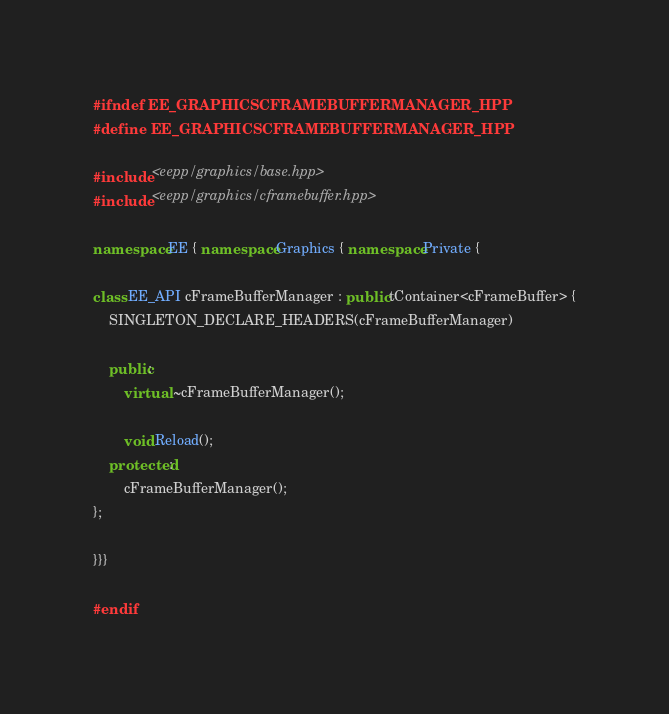<code> <loc_0><loc_0><loc_500><loc_500><_C++_>#ifndef EE_GRAPHICSCFRAMEBUFFERMANAGER_HPP
#define EE_GRAPHICSCFRAMEBUFFERMANAGER_HPP

#include <eepp/graphics/base.hpp>
#include <eepp/graphics/cframebuffer.hpp>

namespace EE { namespace Graphics { namespace Private {

class EE_API cFrameBufferManager : public tContainer<cFrameBuffer> {
	SINGLETON_DECLARE_HEADERS(cFrameBufferManager)

	public:
		virtual ~cFrameBufferManager();

		void Reload();
	protected:
		cFrameBufferManager();
};

}}}

#endif
</code> 